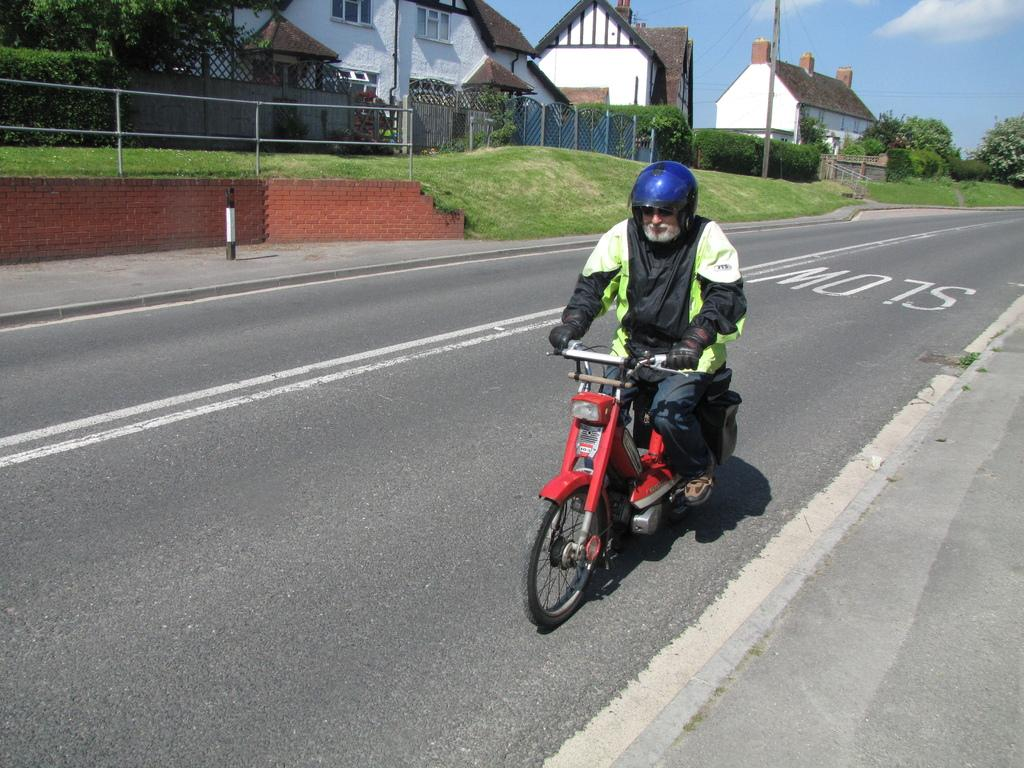What is the person in the image doing? The person is riding a motorbike. What safety precaution is the person taking? The person is wearing a helmet. What can be seen in the background of the image? There are houses with windows, plants, trees, and grass in the background. What type of whistle can be heard in the image? There is no whistle present in the image, and therefore no sound can be heard. 